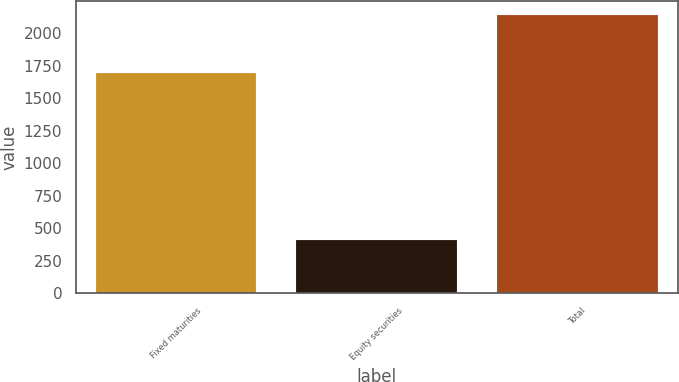Convert chart to OTSL. <chart><loc_0><loc_0><loc_500><loc_500><bar_chart><fcel>Fixed maturities<fcel>Equity securities<fcel>Total<nl><fcel>1694<fcel>409<fcel>2137<nl></chart> 